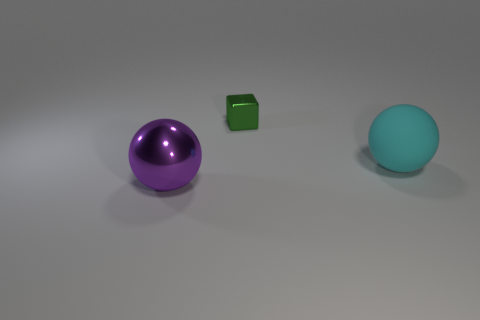What number of other cyan matte balls have the same size as the matte sphere?
Your answer should be compact. 0. Do the cube and the cyan sphere have the same size?
Ensure brevity in your answer.  No. How big is the object that is both in front of the tiny metallic cube and behind the large shiny ball?
Your answer should be compact. Large. Is the number of objects that are behind the purple object greater than the number of objects in front of the shiny block?
Keep it short and to the point. No. What is the color of the rubber object that is the same shape as the big purple metallic thing?
Your answer should be compact. Cyan. How many metallic things are there?
Make the answer very short. 2. Are the green block that is behind the big purple metal sphere and the big purple thing made of the same material?
Your answer should be compact. Yes. Is there any other thing that is made of the same material as the large cyan sphere?
Your answer should be very brief. No. What number of green metal things are in front of the large purple thing to the left of the big sphere on the right side of the large purple object?
Provide a short and direct response. 0. What size is the green cube?
Your answer should be very brief. Small. 